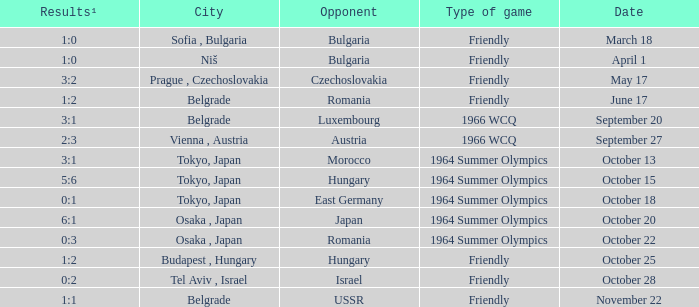Can you parse all the data within this table? {'header': ['Results¹', 'City', 'Opponent', 'Type of game', 'Date'], 'rows': [['1:0', 'Sofia , Bulgaria', 'Bulgaria', 'Friendly', 'March 18'], ['1:0', 'Niš', 'Bulgaria', 'Friendly', 'April 1'], ['3:2', 'Prague , Czechoslovakia', 'Czechoslovakia', 'Friendly', 'May 17'], ['1:2', 'Belgrade', 'Romania', 'Friendly', 'June 17'], ['3:1', 'Belgrade', 'Luxembourg', '1966 WCQ', 'September 20'], ['2:3', 'Vienna , Austria', 'Austria', '1966 WCQ', 'September 27'], ['3:1', 'Tokyo, Japan', 'Morocco', '1964 Summer Olympics', 'October 13'], ['5:6', 'Tokyo, Japan', 'Hungary', '1964 Summer Olympics', 'October 15'], ['0:1', 'Tokyo, Japan', 'East Germany', '1964 Summer Olympics', 'October 18'], ['6:1', 'Osaka , Japan', 'Japan', '1964 Summer Olympics', 'October 20'], ['0:3', 'Osaka , Japan', 'Romania', '1964 Summer Olympics', 'October 22'], ['1:2', 'Budapest , Hungary', 'Hungary', 'Friendly', 'October 25'], ['0:2', 'Tel Aviv , Israel', 'Israel', 'Friendly', 'October 28'], ['1:1', 'Belgrade', 'USSR', 'Friendly', 'November 22']]} What day were the results 3:2? May 17. 